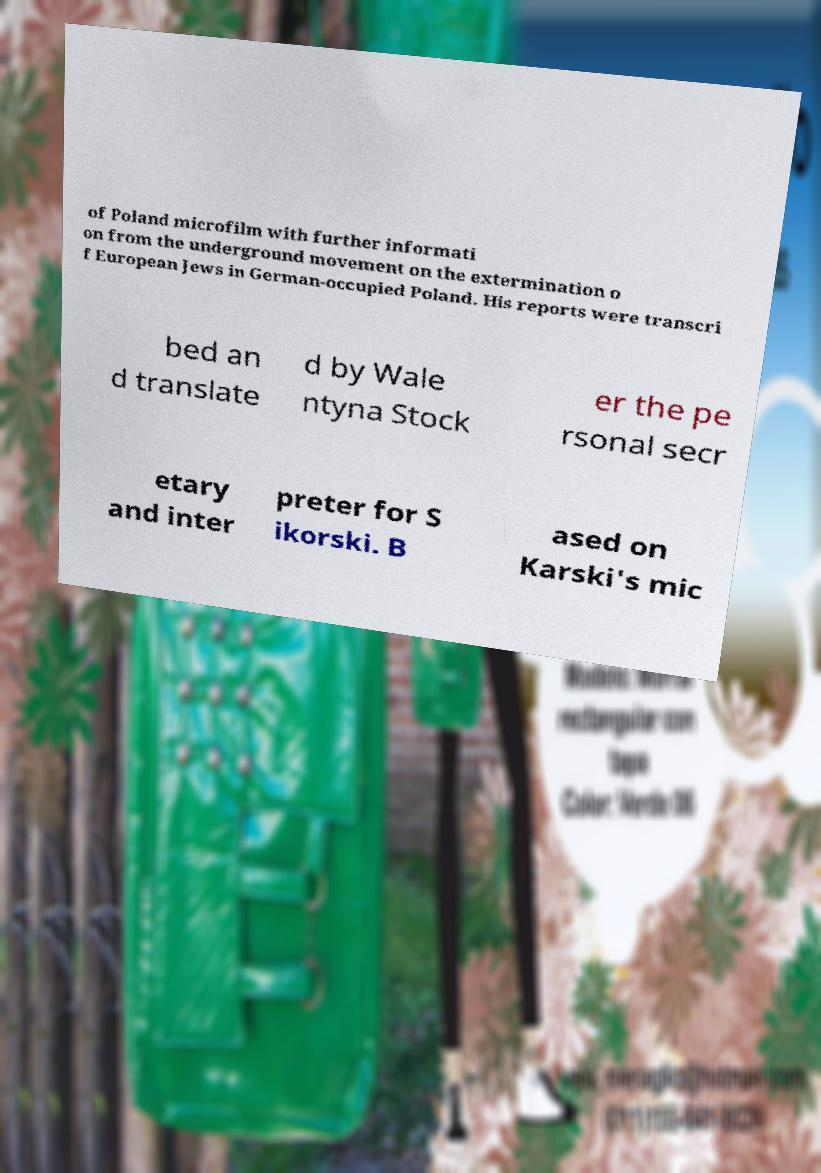There's text embedded in this image that I need extracted. Can you transcribe it verbatim? of Poland microfilm with further informati on from the underground movement on the extermination o f European Jews in German-occupied Poland. His reports were transcri bed an d translate d by Wale ntyna Stock er the pe rsonal secr etary and inter preter for S ikorski. B ased on Karski's mic 